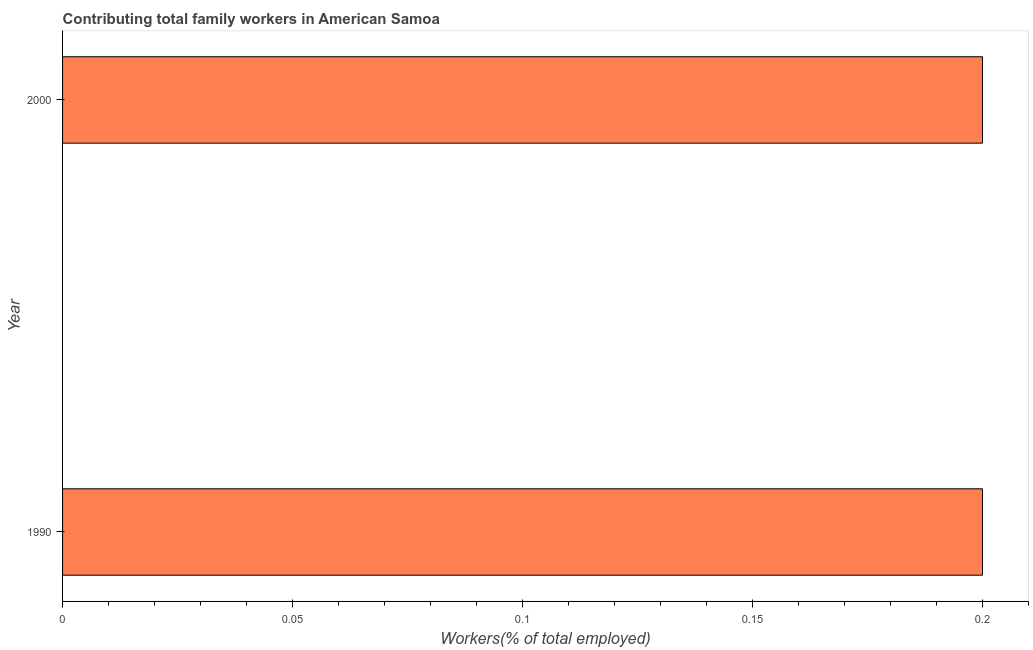Does the graph contain any zero values?
Your answer should be very brief. No. Does the graph contain grids?
Your response must be concise. No. What is the title of the graph?
Give a very brief answer. Contributing total family workers in American Samoa. What is the label or title of the X-axis?
Offer a very short reply. Workers(% of total employed). What is the contributing family workers in 1990?
Offer a terse response. 0.2. Across all years, what is the maximum contributing family workers?
Your answer should be compact. 0.2. Across all years, what is the minimum contributing family workers?
Your response must be concise. 0.2. In which year was the contributing family workers minimum?
Give a very brief answer. 1990. What is the sum of the contributing family workers?
Provide a succinct answer. 0.4. What is the average contributing family workers per year?
Keep it short and to the point. 0.2. What is the median contributing family workers?
Ensure brevity in your answer.  0.2. In how many years, is the contributing family workers greater than 0.16 %?
Make the answer very short. 2. Is the contributing family workers in 1990 less than that in 2000?
Provide a succinct answer. No. How many bars are there?
Keep it short and to the point. 2. Are all the bars in the graph horizontal?
Your answer should be very brief. Yes. What is the difference between two consecutive major ticks on the X-axis?
Your answer should be compact. 0.05. What is the Workers(% of total employed) in 1990?
Ensure brevity in your answer.  0.2. What is the Workers(% of total employed) of 2000?
Give a very brief answer. 0.2. 